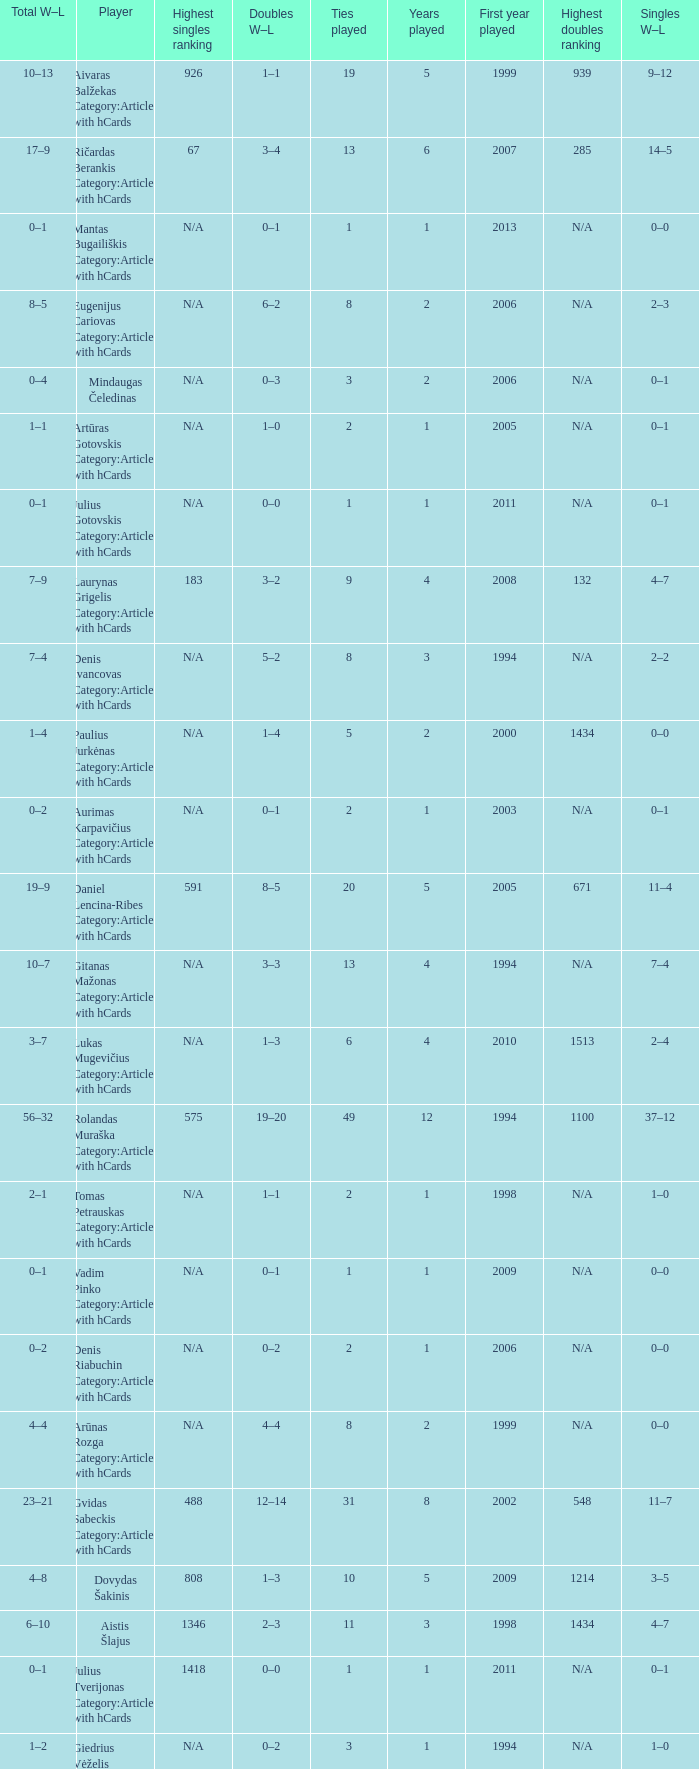Name the minimum tiesplayed for 6 years 13.0. 